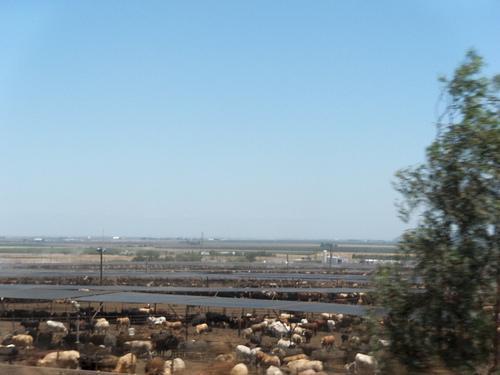How many people are there?
Give a very brief answer. 0. 